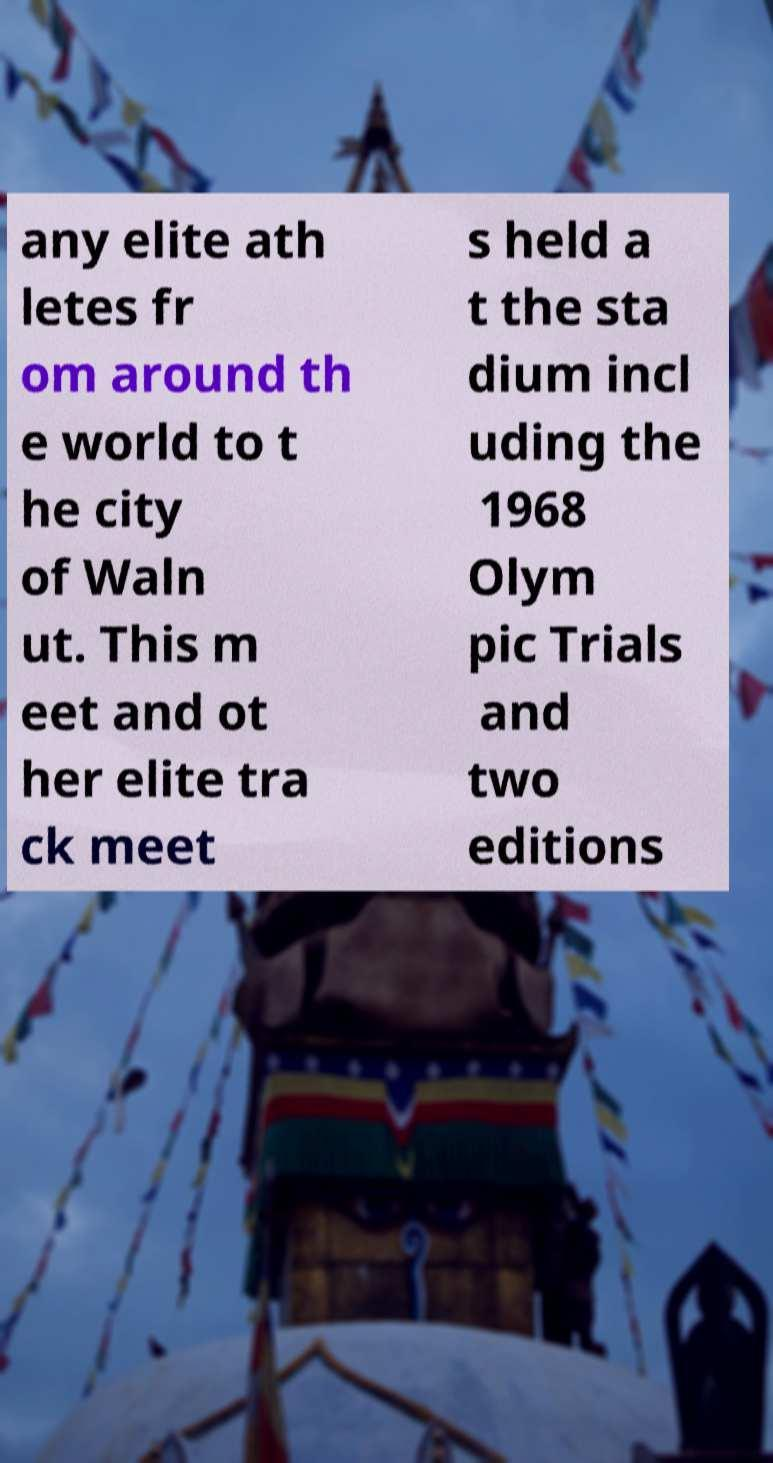Could you extract and type out the text from this image? any elite ath letes fr om around th e world to t he city of Waln ut. This m eet and ot her elite tra ck meet s held a t the sta dium incl uding the 1968 Olym pic Trials and two editions 